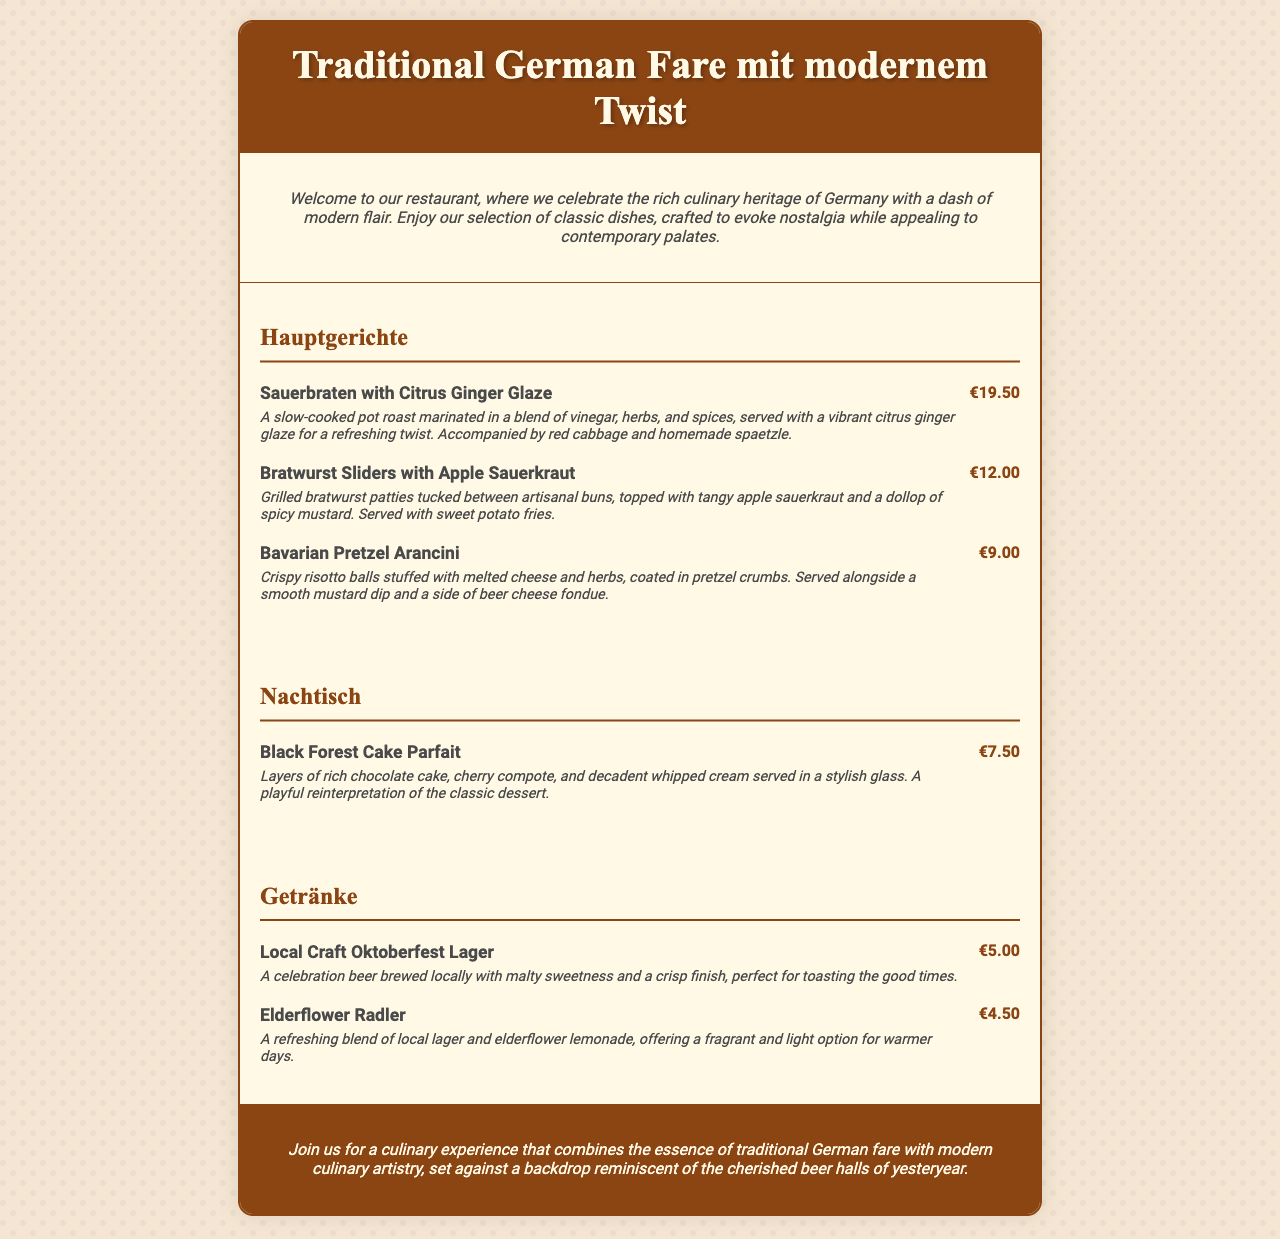what is the name of the first main dish? The first main dish listed in the menu is Sauerbraten with Citrus Ginger Glaze.
Answer: Sauerbraten with Citrus Ginger Glaze how much does the Bavarian Pretzel Arancini cost? The price for the Bavarian Pretzel Arancini is specifically stated on the menu.
Answer: €9.00 what is served with the Bratwurst Sliders? The menu specifies that sweet potato fries are served with the Bratwurst Sliders.
Answer: sweet potato fries what type of dessert is featured on the menu? The menu includes one dessert option, which is a parfait style dish.
Answer: parfait which beverage is described as a celebration beer? The Local Craft Oktoberfest Lager is noted in the beverage section as a celebration beer.
Answer: Local Craft Oktoberfest Lager how many Hauptgerichte are listed on the menu? There are three Hauptgerichte (main dishes) listed in the menu section.
Answer: 3 what is the flavor profile of the Elderflower Radler? The Elderflower Radler is described as a refreshing blend with a light option for warmer days.
Answer: refreshing blend what kind of ambiance does the restaurant aim to evoke? The restaurant aims to create an ambiance reminiscent of cherished beer halls.
Answer: cherished beer halls 